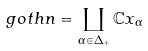<formula> <loc_0><loc_0><loc_500><loc_500>\ g o t h { n } = \coprod _ { \alpha \in \Delta _ { + } } \mathbb { C } x _ { \alpha }</formula> 